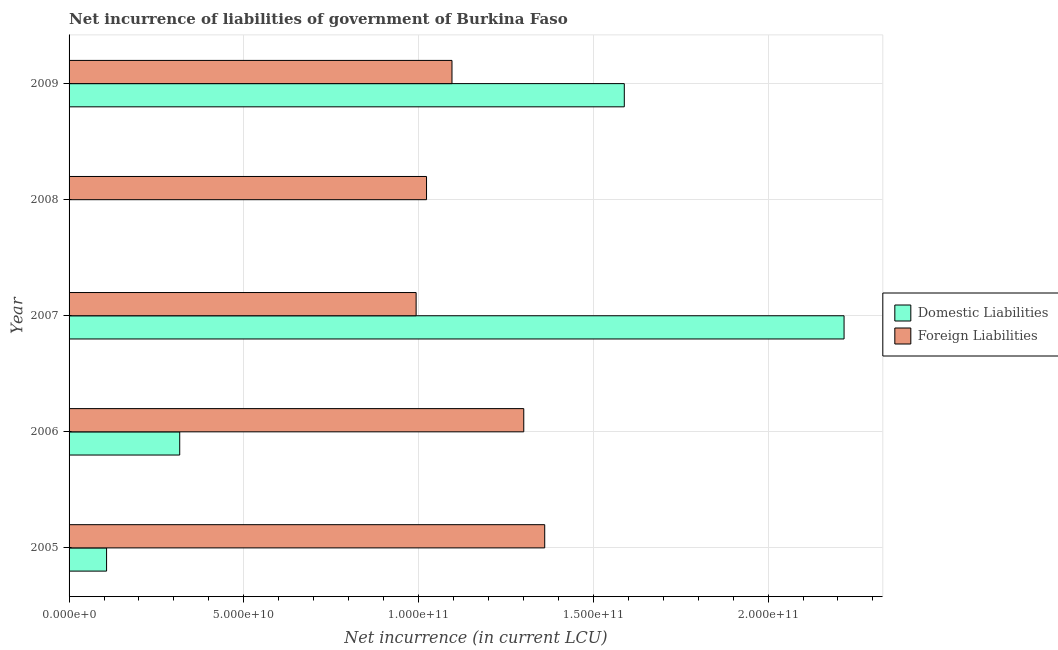How many bars are there on the 2nd tick from the bottom?
Provide a succinct answer. 2. In how many cases, is the number of bars for a given year not equal to the number of legend labels?
Provide a succinct answer. 1. What is the net incurrence of domestic liabilities in 2007?
Offer a terse response. 2.22e+11. Across all years, what is the maximum net incurrence of domestic liabilities?
Provide a short and direct response. 2.22e+11. What is the total net incurrence of domestic liabilities in the graph?
Keep it short and to the point. 4.23e+11. What is the difference between the net incurrence of domestic liabilities in 2005 and that in 2009?
Provide a short and direct response. -1.48e+11. What is the difference between the net incurrence of domestic liabilities in 2006 and the net incurrence of foreign liabilities in 2008?
Provide a short and direct response. -7.06e+1. What is the average net incurrence of domestic liabilities per year?
Give a very brief answer. 8.46e+1. In the year 2007, what is the difference between the net incurrence of foreign liabilities and net incurrence of domestic liabilities?
Your answer should be compact. -1.22e+11. In how many years, is the net incurrence of domestic liabilities greater than 40000000000 LCU?
Keep it short and to the point. 2. What is the ratio of the net incurrence of foreign liabilities in 2006 to that in 2008?
Offer a very short reply. 1.27. Is the net incurrence of foreign liabilities in 2007 less than that in 2009?
Ensure brevity in your answer.  Yes. Is the difference between the net incurrence of domestic liabilities in 2005 and 2007 greater than the difference between the net incurrence of foreign liabilities in 2005 and 2007?
Give a very brief answer. No. What is the difference between the highest and the second highest net incurrence of foreign liabilities?
Ensure brevity in your answer.  5.99e+09. What is the difference between the highest and the lowest net incurrence of domestic liabilities?
Ensure brevity in your answer.  2.22e+11. Is the sum of the net incurrence of foreign liabilities in 2006 and 2008 greater than the maximum net incurrence of domestic liabilities across all years?
Provide a short and direct response. Yes. Are all the bars in the graph horizontal?
Your response must be concise. Yes. How many years are there in the graph?
Provide a succinct answer. 5. Does the graph contain any zero values?
Provide a short and direct response. Yes. Does the graph contain grids?
Your answer should be compact. Yes. Where does the legend appear in the graph?
Make the answer very short. Center right. How many legend labels are there?
Your answer should be very brief. 2. How are the legend labels stacked?
Your response must be concise. Vertical. What is the title of the graph?
Keep it short and to the point. Net incurrence of liabilities of government of Burkina Faso. What is the label or title of the X-axis?
Ensure brevity in your answer.  Net incurrence (in current LCU). What is the label or title of the Y-axis?
Provide a succinct answer. Year. What is the Net incurrence (in current LCU) in Domestic Liabilities in 2005?
Give a very brief answer. 1.07e+1. What is the Net incurrence (in current LCU) of Foreign Liabilities in 2005?
Your answer should be very brief. 1.36e+11. What is the Net incurrence (in current LCU) of Domestic Liabilities in 2006?
Provide a succinct answer. 3.17e+1. What is the Net incurrence (in current LCU) of Foreign Liabilities in 2006?
Offer a very short reply. 1.30e+11. What is the Net incurrence (in current LCU) of Domestic Liabilities in 2007?
Provide a succinct answer. 2.22e+11. What is the Net incurrence (in current LCU) of Foreign Liabilities in 2007?
Give a very brief answer. 9.93e+1. What is the Net incurrence (in current LCU) of Foreign Liabilities in 2008?
Ensure brevity in your answer.  1.02e+11. What is the Net incurrence (in current LCU) of Domestic Liabilities in 2009?
Your answer should be compact. 1.59e+11. What is the Net incurrence (in current LCU) in Foreign Liabilities in 2009?
Give a very brief answer. 1.10e+11. Across all years, what is the maximum Net incurrence (in current LCU) of Domestic Liabilities?
Ensure brevity in your answer.  2.22e+11. Across all years, what is the maximum Net incurrence (in current LCU) of Foreign Liabilities?
Keep it short and to the point. 1.36e+11. Across all years, what is the minimum Net incurrence (in current LCU) of Foreign Liabilities?
Provide a short and direct response. 9.93e+1. What is the total Net incurrence (in current LCU) of Domestic Liabilities in the graph?
Make the answer very short. 4.23e+11. What is the total Net incurrence (in current LCU) in Foreign Liabilities in the graph?
Offer a very short reply. 5.77e+11. What is the difference between the Net incurrence (in current LCU) in Domestic Liabilities in 2005 and that in 2006?
Provide a short and direct response. -2.09e+1. What is the difference between the Net incurrence (in current LCU) of Foreign Liabilities in 2005 and that in 2006?
Offer a terse response. 5.99e+09. What is the difference between the Net incurrence (in current LCU) of Domestic Liabilities in 2005 and that in 2007?
Your response must be concise. -2.11e+11. What is the difference between the Net incurrence (in current LCU) in Foreign Liabilities in 2005 and that in 2007?
Offer a very short reply. 3.68e+1. What is the difference between the Net incurrence (in current LCU) of Foreign Liabilities in 2005 and that in 2008?
Your response must be concise. 3.38e+1. What is the difference between the Net incurrence (in current LCU) of Domestic Liabilities in 2005 and that in 2009?
Offer a terse response. -1.48e+11. What is the difference between the Net incurrence (in current LCU) in Foreign Liabilities in 2005 and that in 2009?
Your answer should be very brief. 2.65e+1. What is the difference between the Net incurrence (in current LCU) of Domestic Liabilities in 2006 and that in 2007?
Provide a short and direct response. -1.90e+11. What is the difference between the Net incurrence (in current LCU) in Foreign Liabilities in 2006 and that in 2007?
Provide a short and direct response. 3.08e+1. What is the difference between the Net incurrence (in current LCU) of Foreign Liabilities in 2006 and that in 2008?
Keep it short and to the point. 2.78e+1. What is the difference between the Net incurrence (in current LCU) of Domestic Liabilities in 2006 and that in 2009?
Provide a succinct answer. -1.27e+11. What is the difference between the Net incurrence (in current LCU) in Foreign Liabilities in 2006 and that in 2009?
Provide a succinct answer. 2.05e+1. What is the difference between the Net incurrence (in current LCU) of Foreign Liabilities in 2007 and that in 2008?
Make the answer very short. -2.98e+09. What is the difference between the Net incurrence (in current LCU) in Domestic Liabilities in 2007 and that in 2009?
Your answer should be very brief. 6.29e+1. What is the difference between the Net incurrence (in current LCU) in Foreign Liabilities in 2007 and that in 2009?
Give a very brief answer. -1.03e+1. What is the difference between the Net incurrence (in current LCU) of Foreign Liabilities in 2008 and that in 2009?
Your answer should be compact. -7.28e+09. What is the difference between the Net incurrence (in current LCU) of Domestic Liabilities in 2005 and the Net incurrence (in current LCU) of Foreign Liabilities in 2006?
Ensure brevity in your answer.  -1.19e+11. What is the difference between the Net incurrence (in current LCU) of Domestic Liabilities in 2005 and the Net incurrence (in current LCU) of Foreign Liabilities in 2007?
Keep it short and to the point. -8.86e+1. What is the difference between the Net incurrence (in current LCU) in Domestic Liabilities in 2005 and the Net incurrence (in current LCU) in Foreign Liabilities in 2008?
Offer a terse response. -9.15e+1. What is the difference between the Net incurrence (in current LCU) in Domestic Liabilities in 2005 and the Net incurrence (in current LCU) in Foreign Liabilities in 2009?
Ensure brevity in your answer.  -9.88e+1. What is the difference between the Net incurrence (in current LCU) in Domestic Liabilities in 2006 and the Net incurrence (in current LCU) in Foreign Liabilities in 2007?
Provide a short and direct response. -6.76e+1. What is the difference between the Net incurrence (in current LCU) of Domestic Liabilities in 2006 and the Net incurrence (in current LCU) of Foreign Liabilities in 2008?
Your response must be concise. -7.06e+1. What is the difference between the Net incurrence (in current LCU) in Domestic Liabilities in 2006 and the Net incurrence (in current LCU) in Foreign Liabilities in 2009?
Give a very brief answer. -7.79e+1. What is the difference between the Net incurrence (in current LCU) in Domestic Liabilities in 2007 and the Net incurrence (in current LCU) in Foreign Liabilities in 2008?
Give a very brief answer. 1.19e+11. What is the difference between the Net incurrence (in current LCU) in Domestic Liabilities in 2007 and the Net incurrence (in current LCU) in Foreign Liabilities in 2009?
Ensure brevity in your answer.  1.12e+11. What is the average Net incurrence (in current LCU) of Domestic Liabilities per year?
Keep it short and to the point. 8.46e+1. What is the average Net incurrence (in current LCU) in Foreign Liabilities per year?
Offer a very short reply. 1.15e+11. In the year 2005, what is the difference between the Net incurrence (in current LCU) in Domestic Liabilities and Net incurrence (in current LCU) in Foreign Liabilities?
Provide a short and direct response. -1.25e+11. In the year 2006, what is the difference between the Net incurrence (in current LCU) in Domestic Liabilities and Net incurrence (in current LCU) in Foreign Liabilities?
Give a very brief answer. -9.84e+1. In the year 2007, what is the difference between the Net incurrence (in current LCU) of Domestic Liabilities and Net incurrence (in current LCU) of Foreign Liabilities?
Provide a succinct answer. 1.22e+11. In the year 2009, what is the difference between the Net incurrence (in current LCU) of Domestic Liabilities and Net incurrence (in current LCU) of Foreign Liabilities?
Provide a short and direct response. 4.93e+1. What is the ratio of the Net incurrence (in current LCU) of Domestic Liabilities in 2005 to that in 2006?
Your answer should be compact. 0.34. What is the ratio of the Net incurrence (in current LCU) in Foreign Liabilities in 2005 to that in 2006?
Offer a terse response. 1.05. What is the ratio of the Net incurrence (in current LCU) in Domestic Liabilities in 2005 to that in 2007?
Your response must be concise. 0.05. What is the ratio of the Net incurrence (in current LCU) in Foreign Liabilities in 2005 to that in 2007?
Offer a very short reply. 1.37. What is the ratio of the Net incurrence (in current LCU) in Foreign Liabilities in 2005 to that in 2008?
Your response must be concise. 1.33. What is the ratio of the Net incurrence (in current LCU) in Domestic Liabilities in 2005 to that in 2009?
Offer a very short reply. 0.07. What is the ratio of the Net incurrence (in current LCU) of Foreign Liabilities in 2005 to that in 2009?
Provide a short and direct response. 1.24. What is the ratio of the Net incurrence (in current LCU) in Domestic Liabilities in 2006 to that in 2007?
Your response must be concise. 0.14. What is the ratio of the Net incurrence (in current LCU) of Foreign Liabilities in 2006 to that in 2007?
Offer a very short reply. 1.31. What is the ratio of the Net incurrence (in current LCU) in Foreign Liabilities in 2006 to that in 2008?
Provide a short and direct response. 1.27. What is the ratio of the Net incurrence (in current LCU) of Domestic Liabilities in 2006 to that in 2009?
Ensure brevity in your answer.  0.2. What is the ratio of the Net incurrence (in current LCU) of Foreign Liabilities in 2006 to that in 2009?
Make the answer very short. 1.19. What is the ratio of the Net incurrence (in current LCU) in Foreign Liabilities in 2007 to that in 2008?
Give a very brief answer. 0.97. What is the ratio of the Net incurrence (in current LCU) in Domestic Liabilities in 2007 to that in 2009?
Provide a succinct answer. 1.4. What is the ratio of the Net incurrence (in current LCU) of Foreign Liabilities in 2007 to that in 2009?
Give a very brief answer. 0.91. What is the ratio of the Net incurrence (in current LCU) of Foreign Liabilities in 2008 to that in 2009?
Your answer should be compact. 0.93. What is the difference between the highest and the second highest Net incurrence (in current LCU) in Domestic Liabilities?
Offer a very short reply. 6.29e+1. What is the difference between the highest and the second highest Net incurrence (in current LCU) in Foreign Liabilities?
Your answer should be very brief. 5.99e+09. What is the difference between the highest and the lowest Net incurrence (in current LCU) in Domestic Liabilities?
Your answer should be compact. 2.22e+11. What is the difference between the highest and the lowest Net incurrence (in current LCU) of Foreign Liabilities?
Provide a short and direct response. 3.68e+1. 